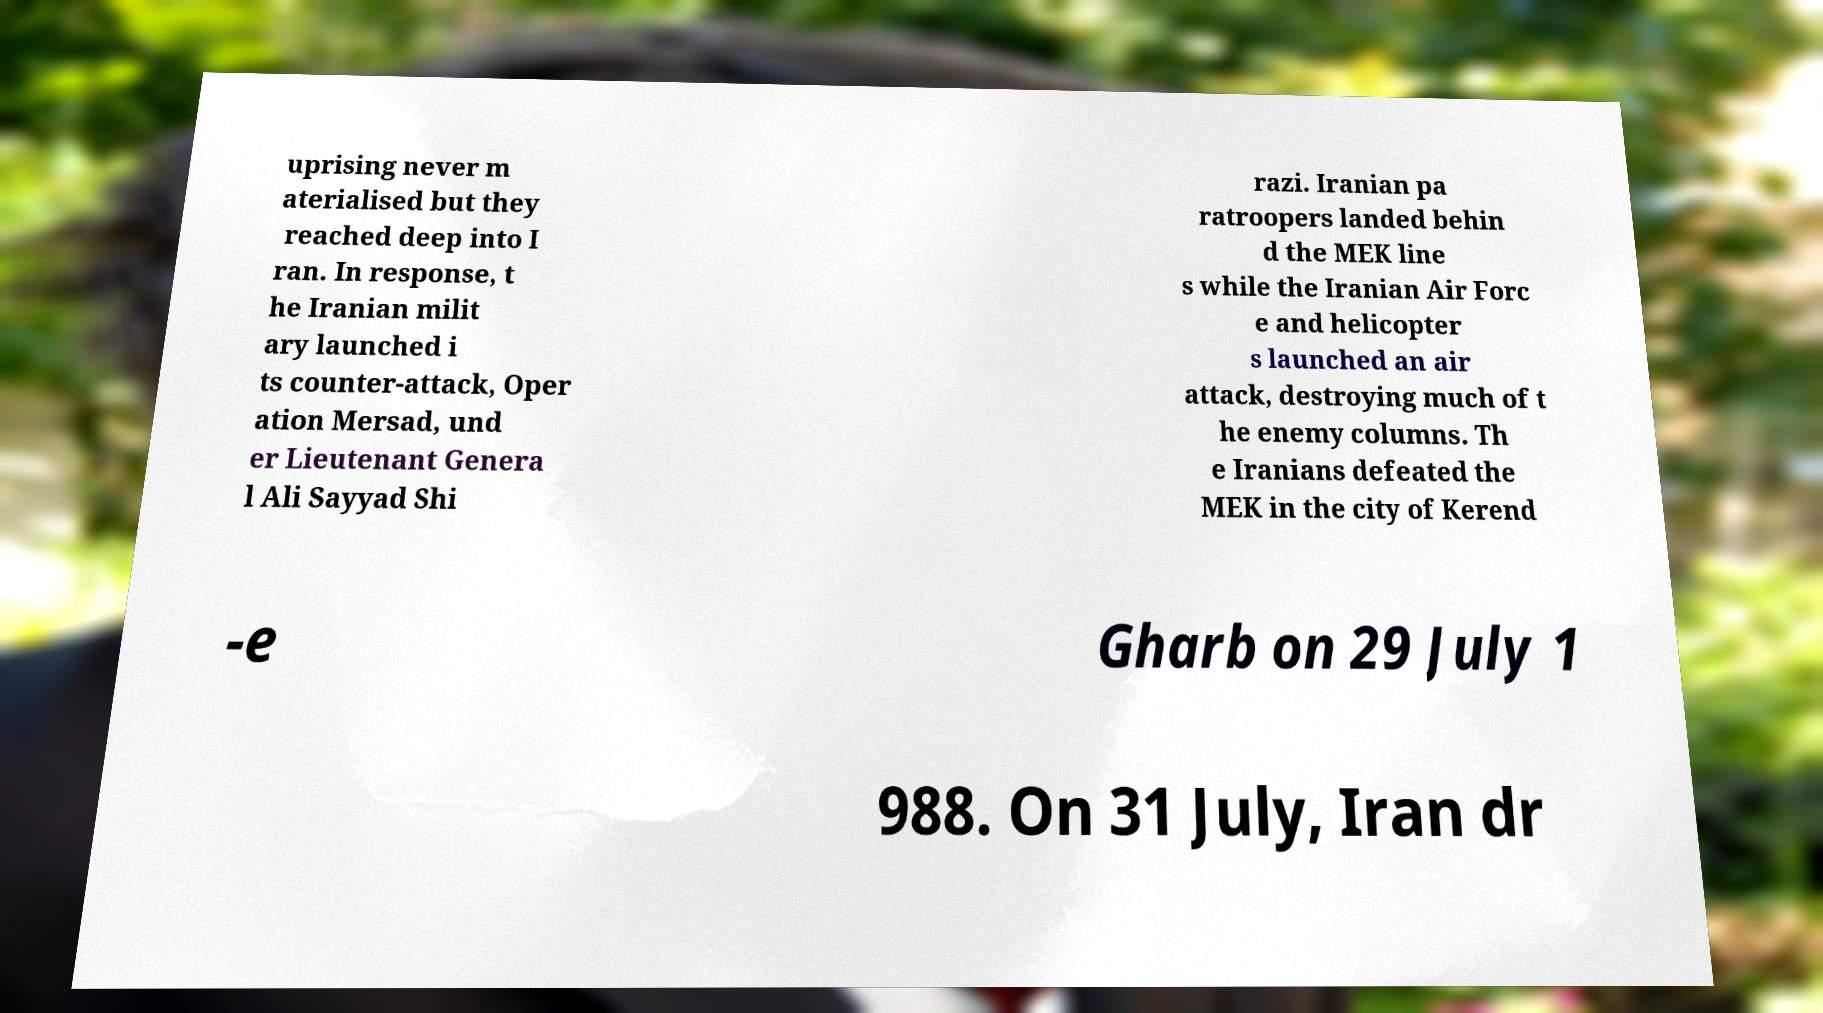Could you assist in decoding the text presented in this image and type it out clearly? uprising never m aterialised but they reached deep into I ran. In response, t he Iranian milit ary launched i ts counter-attack, Oper ation Mersad, und er Lieutenant Genera l Ali Sayyad Shi razi. Iranian pa ratroopers landed behin d the MEK line s while the Iranian Air Forc e and helicopter s launched an air attack, destroying much of t he enemy columns. Th e Iranians defeated the MEK in the city of Kerend -e Gharb on 29 July 1 988. On 31 July, Iran dr 